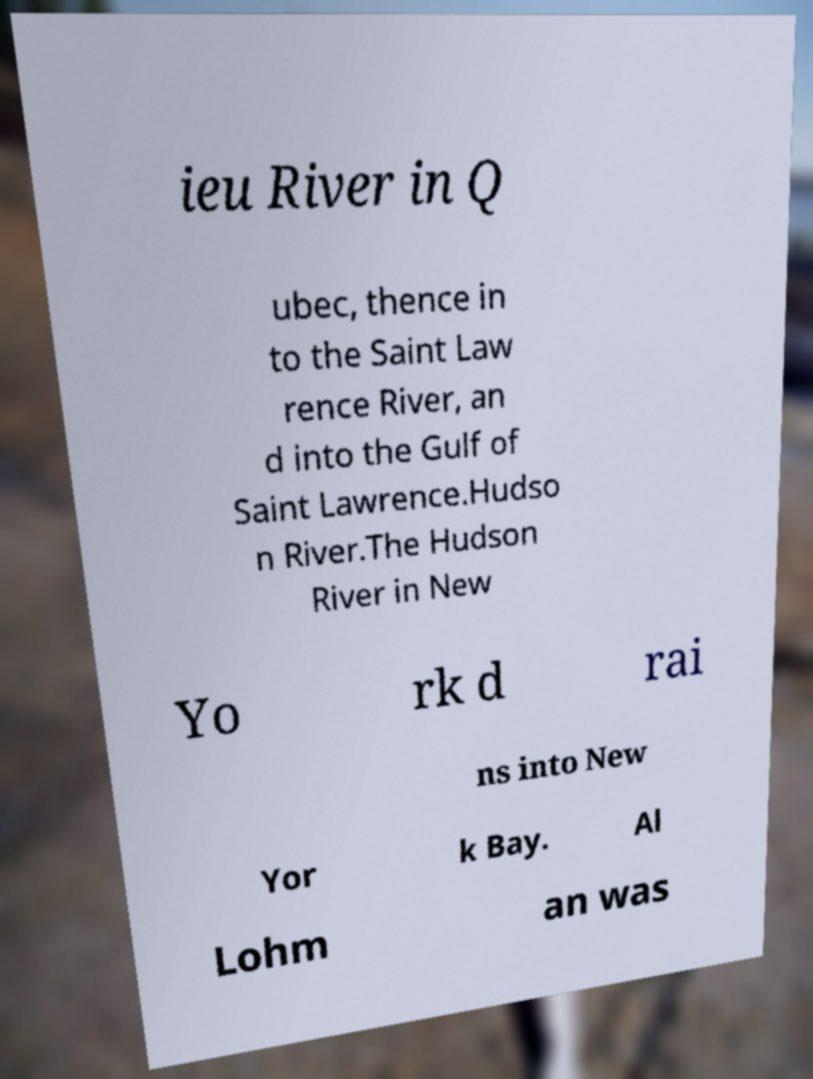Can you read and provide the text displayed in the image?This photo seems to have some interesting text. Can you extract and type it out for me? ieu River in Q ubec, thence in to the Saint Law rence River, an d into the Gulf of Saint Lawrence.Hudso n River.The Hudson River in New Yo rk d rai ns into New Yor k Bay. Al Lohm an was 